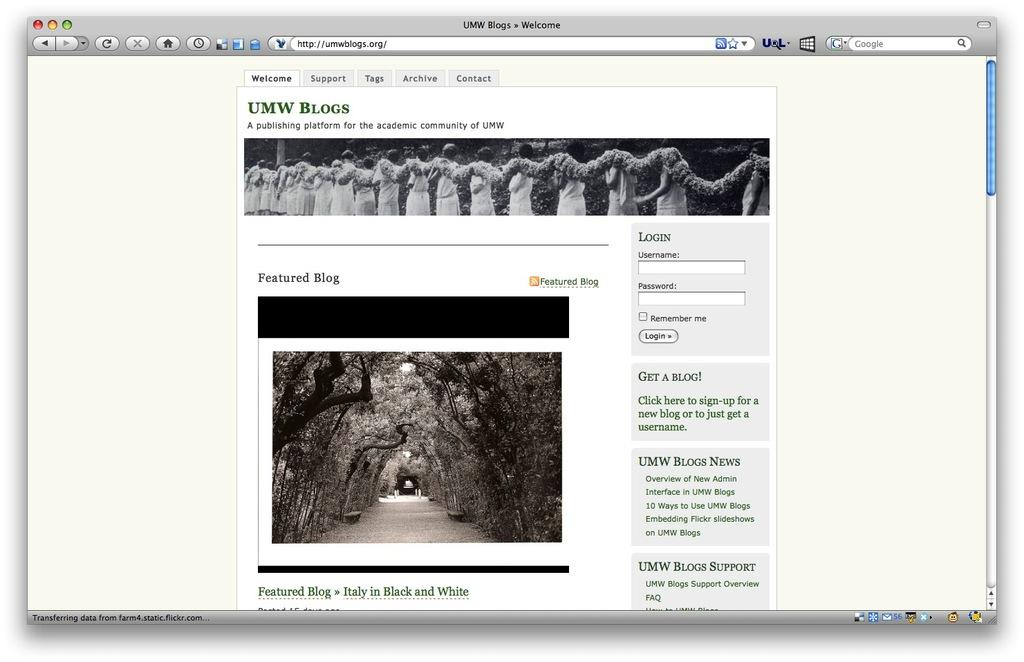What is the primary element of the image? The image contains a screenshot of a screen. How many pieces of beef can be seen in the image? There is no beef present in the image, as it contains a screenshot of a screen. 